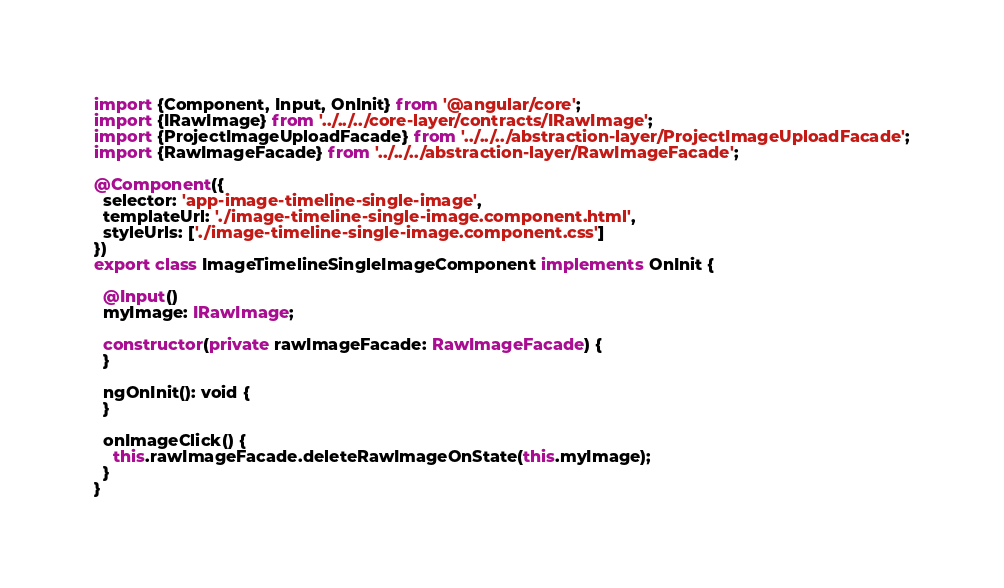Convert code to text. <code><loc_0><loc_0><loc_500><loc_500><_TypeScript_>import {Component, Input, OnInit} from '@angular/core';
import {IRawImage} from '../../../core-layer/contracts/IRawImage';
import {ProjectImageUploadFacade} from '../../../abstraction-layer/ProjectImageUploadFacade';
import {RawImageFacade} from '../../../abstraction-layer/RawImageFacade';

@Component({
  selector: 'app-image-timeline-single-image',
  templateUrl: './image-timeline-single-image.component.html',
  styleUrls: ['./image-timeline-single-image.component.css']
})
export class ImageTimelineSingleImageComponent implements OnInit {

  @Input()
  myImage: IRawImage;

  constructor(private rawImageFacade: RawImageFacade) {
  }

  ngOnInit(): void {
  }

  onImageClick() {
    this.rawImageFacade.deleteRawImageOnState(this.myImage);
  }
}
</code> 